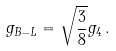Convert formula to latex. <formula><loc_0><loc_0><loc_500><loc_500>g _ { B - L } = \sqrt { \frac { 3 } { 8 } } g _ { 4 } \, .</formula> 